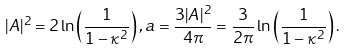<formula> <loc_0><loc_0><loc_500><loc_500>| A | ^ { 2 } = 2 \ln \left ( \frac { 1 } { 1 - \kappa ^ { 2 } } \right ) , a = \frac { 3 | A | ^ { 2 } } { 4 \pi } = \frac { 3 } { 2 \pi } \ln \left ( \frac { 1 } { 1 - \kappa ^ { 2 } } \right ) .</formula> 